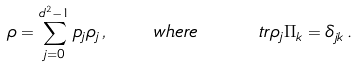Convert formula to latex. <formula><loc_0><loc_0><loc_500><loc_500>\rho = \sum _ { j = 0 } ^ { d ^ { 2 } - 1 } p _ { j } \rho _ { j } \, , \quad w h e r e \quad \ t r { \rho _ { j } \Pi _ { k } } = \delta _ { j k } \, .</formula> 